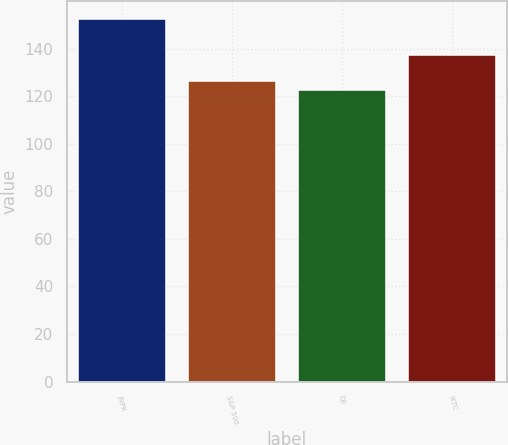<chart> <loc_0><loc_0><loc_500><loc_500><bar_chart><fcel>JNPR<fcel>S&P 500<fcel>DJI<fcel>IXTC<nl><fcel>152.31<fcel>126.46<fcel>122.6<fcel>137.19<nl></chart> 